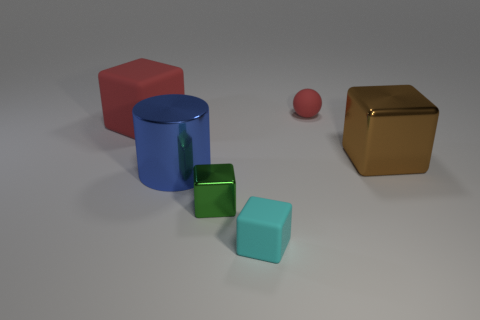There is a matte block that is the same color as the small rubber ball; what is its size?
Your response must be concise. Large. Are there any other things that are the same shape as the small red matte object?
Give a very brief answer. No. There is a cyan object that is the same size as the rubber sphere; what shape is it?
Your answer should be compact. Cube. There is a red matte thing behind the big rubber block; does it have the same size as the metallic cube to the left of the matte ball?
Offer a very short reply. Yes. How big is the red object left of the tiny metal block?
Ensure brevity in your answer.  Large. There is another matte block that is the same size as the brown block; what color is it?
Your answer should be very brief. Red. Do the blue metallic object and the brown shiny cube have the same size?
Ensure brevity in your answer.  Yes. There is a matte object that is both right of the big blue cylinder and in front of the small red rubber object; how big is it?
Make the answer very short. Small. How many metal things are either large red cubes or purple spheres?
Your answer should be compact. 0. Is the number of big shiny things to the right of the green metal thing greater than the number of gray rubber blocks?
Your answer should be very brief. Yes. 